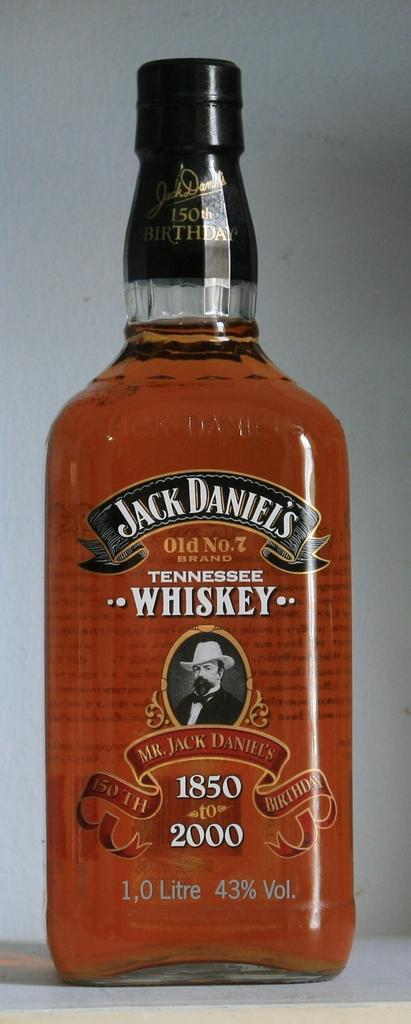In one or two sentences, can you explain what this image depicts? In this Image I see a bottle on which there are few words written on it and I see a man picture. 